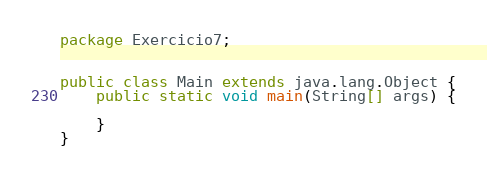Convert code to text. <code><loc_0><loc_0><loc_500><loc_500><_Java_>package Exercicio7;

    
public class Main extends java.lang.Object {
    public static void main(String[] args) {

    }
}
</code> 